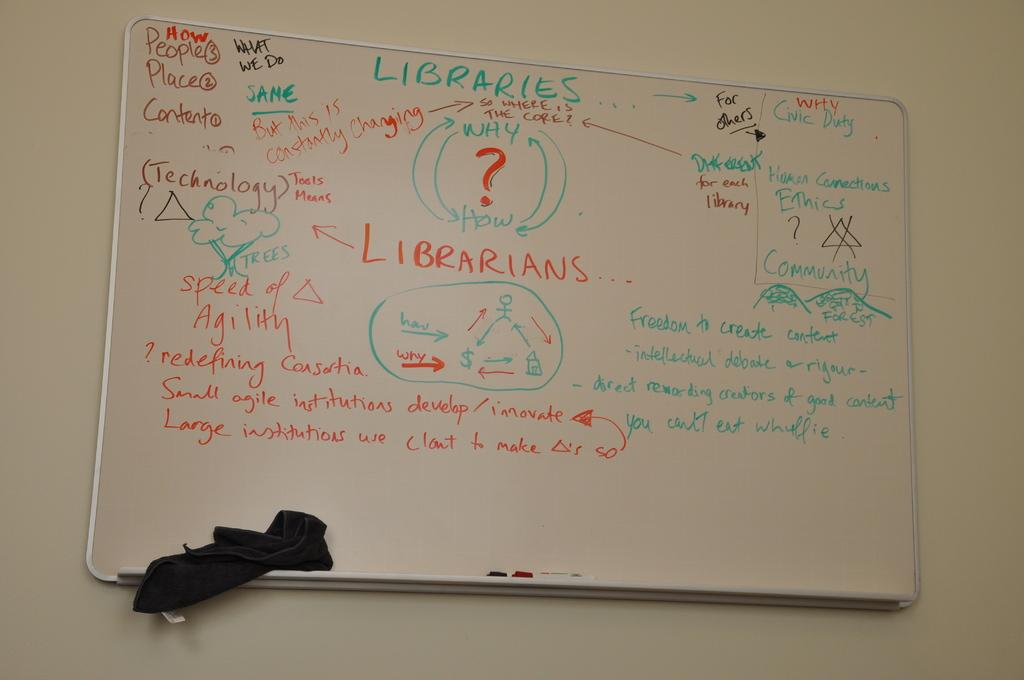What is the main object in the image? There is a white color board in the image. What is on the color board? The board contains texts and drawings. Where is the color board located? The board is attached to a white wall. Is there a boat visible in the image? No, there is no boat present in the image. Which direction is the north indicated on the color board? The image does not show any indication of north or any directional information. 